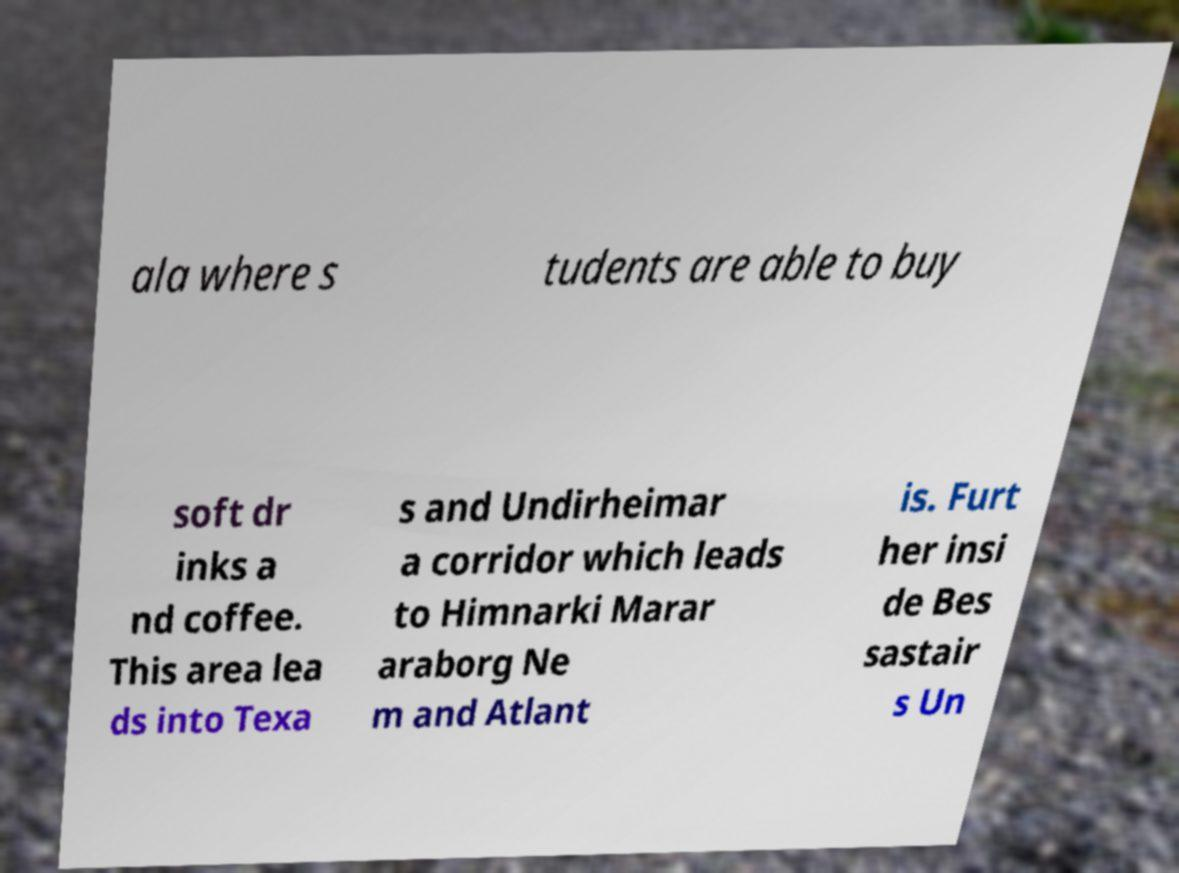For documentation purposes, I need the text within this image transcribed. Could you provide that? ala where s tudents are able to buy soft dr inks a nd coffee. This area lea ds into Texa s and Undirheimar a corridor which leads to Himnarki Marar araborg Ne m and Atlant is. Furt her insi de Bes sastair s Un 